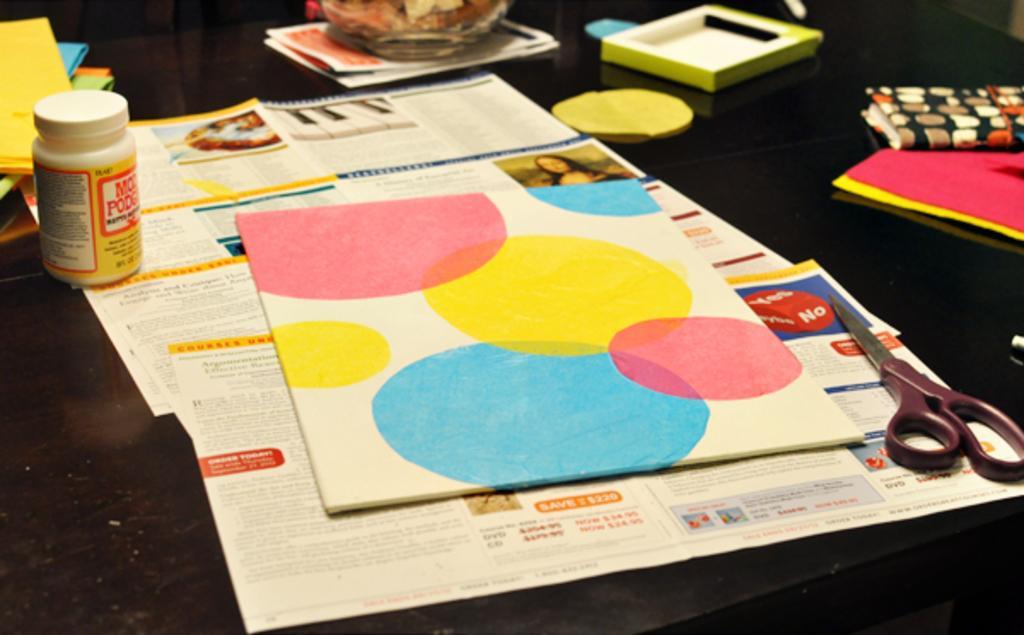Describe this image in one or two sentences. This image consists of papers, scissors, small bottles, books. 